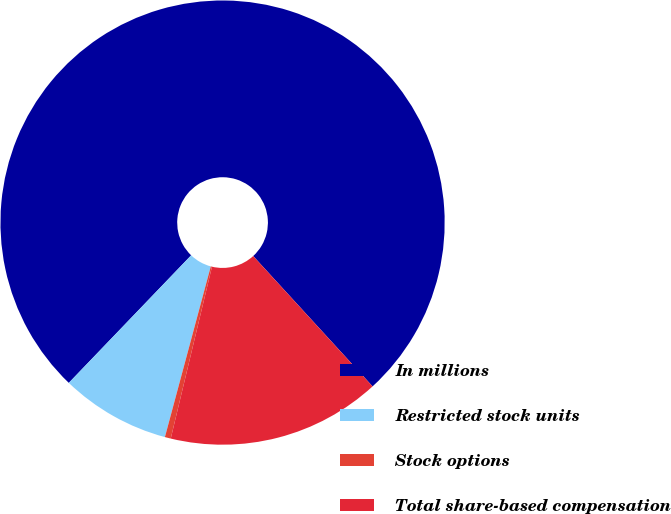Convert chart to OTSL. <chart><loc_0><loc_0><loc_500><loc_500><pie_chart><fcel>In millions<fcel>Restricted stock units<fcel>Stock options<fcel>Total share-based compensation<nl><fcel>76.03%<fcel>7.99%<fcel>0.43%<fcel>15.55%<nl></chart> 